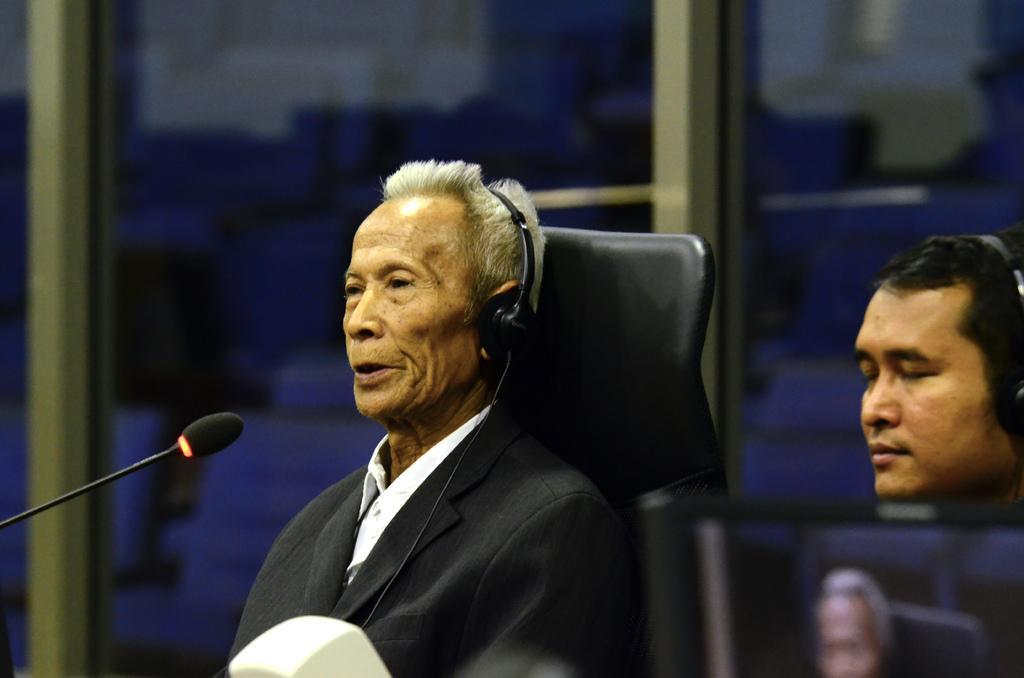Could you give a brief overview of what you see in this image? In the image we can see two men wearing clothes and headsets. This is a microphone, chair and a glass window. 